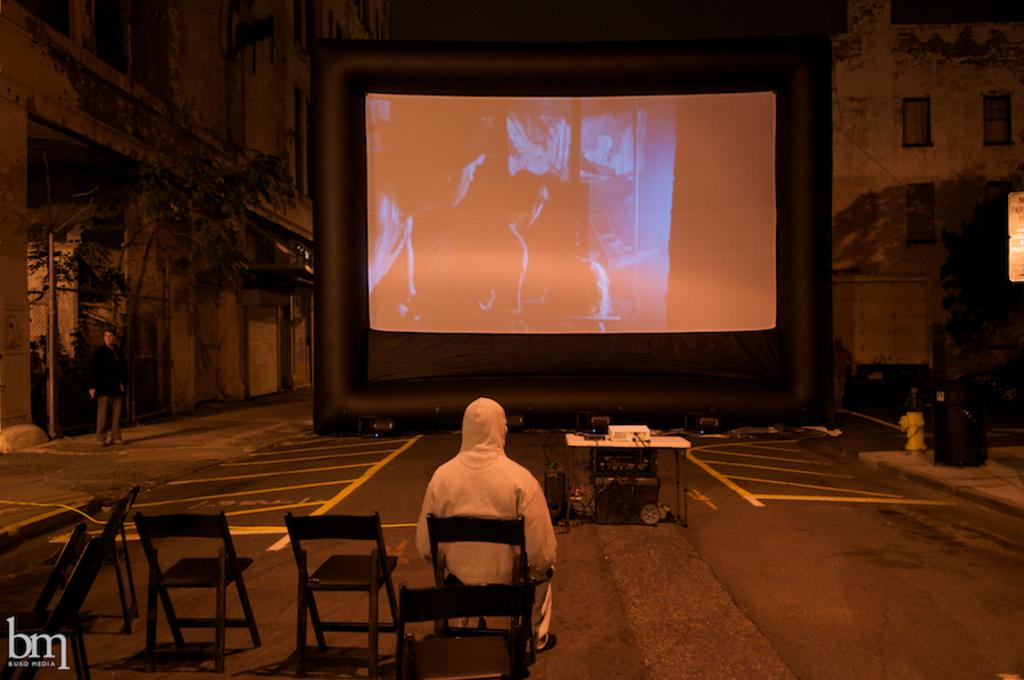What is the person in the image doing? The person is sitting on a chair and watching a movie. What is in front of the person? The person is in front of a screen. What object is used to display the movie? A projector is placed on a wooden table in the image. What type of structure is visible in the image? There is a house visible in the image. What natural element is present in the image? There is a tree in the image. What type of soup is the person eating in the image? There is no soup present in the image; the person is watching a movie. Can you tell me where the person's mom is in the image? There is no information about the person's mom in the image. Is there a bear visible in the image? No, there is no bear present in the image. 